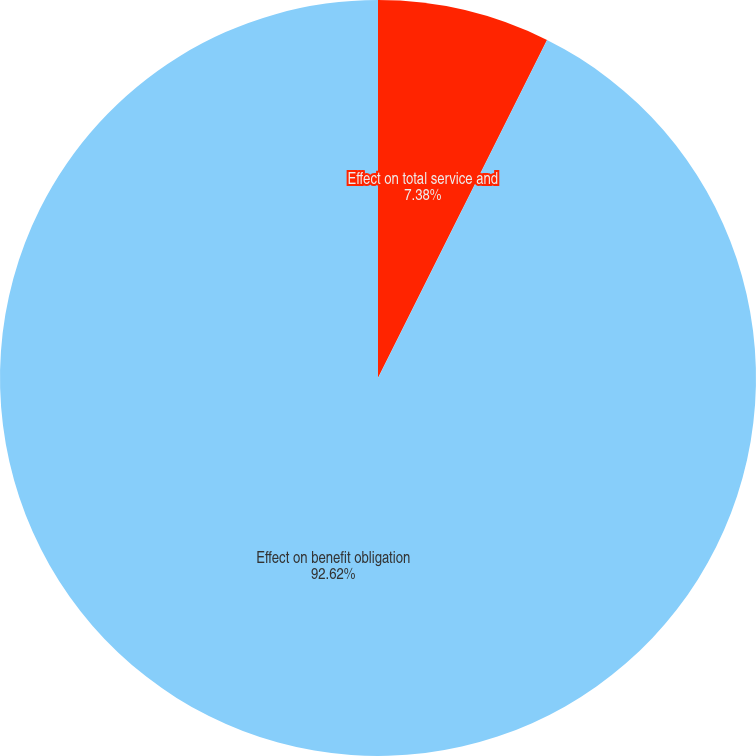Convert chart. <chart><loc_0><loc_0><loc_500><loc_500><pie_chart><fcel>Effect on total service and<fcel>Effect on benefit obligation<nl><fcel>7.38%<fcel>92.62%<nl></chart> 